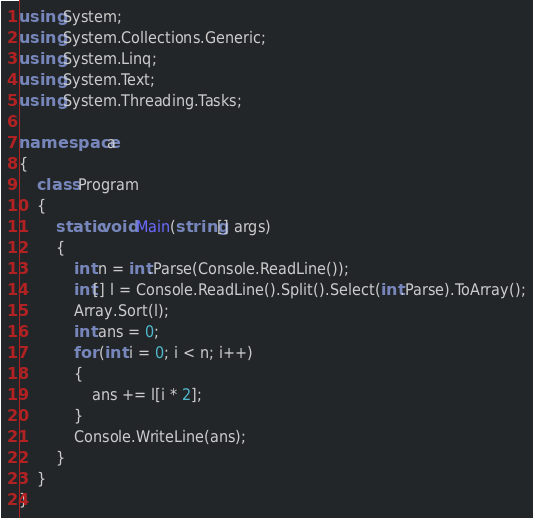Convert code to text. <code><loc_0><loc_0><loc_500><loc_500><_C#_>using System;
using System.Collections.Generic;
using System.Linq;
using System.Text;
using System.Threading.Tasks;

namespace a
{
    class Program
    {
        static void Main(string[] args)
        {
            int n = int.Parse(Console.ReadLine());
            int[] l = Console.ReadLine().Split().Select(int.Parse).ToArray();
            Array.Sort(l);
            int ans = 0;
            for (int i = 0; i < n; i++)
            {
                ans += l[i * 2];
            }
            Console.WriteLine(ans);
        }
    }
}
</code> 